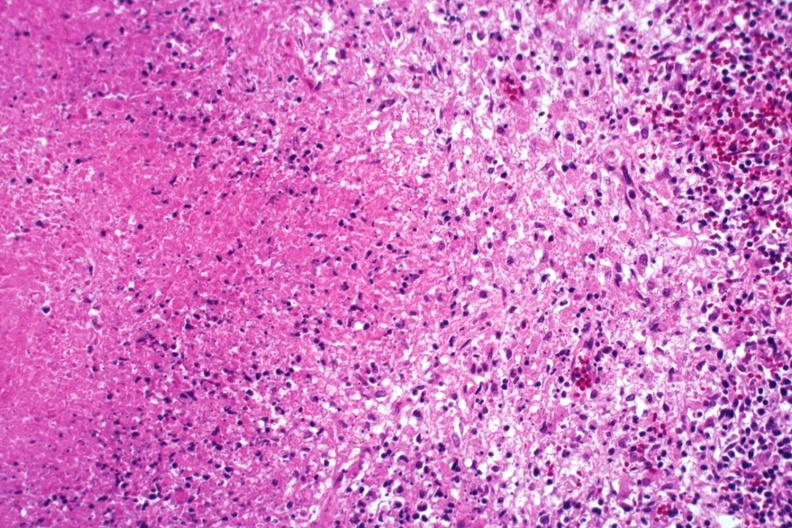s stein leventhal present?
Answer the question using a single word or phrase. No 